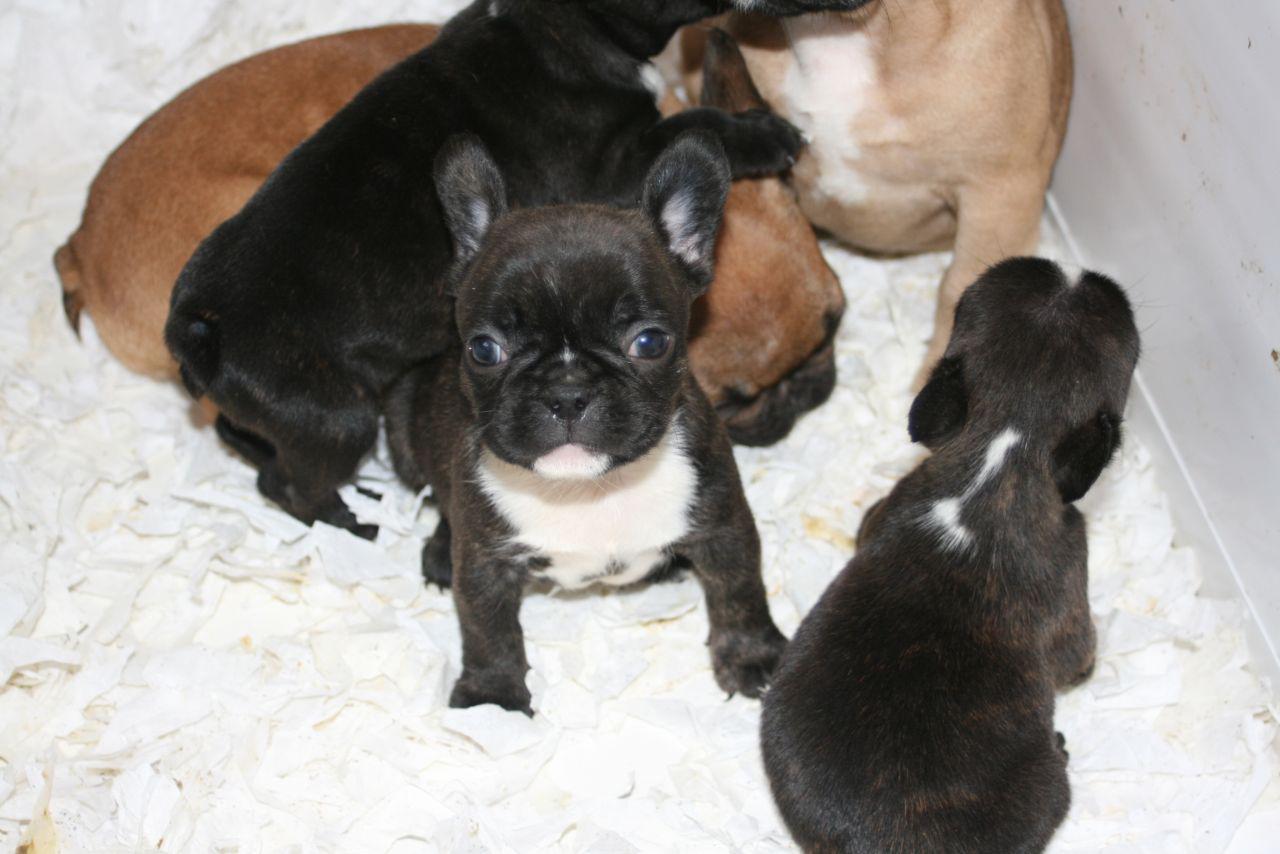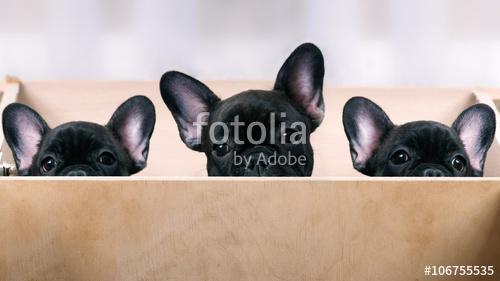The first image is the image on the left, the second image is the image on the right. Assess this claim about the two images: "The right image contains exactly three dogs.". Correct or not? Answer yes or no. Yes. The first image is the image on the left, the second image is the image on the right. Assess this claim about the two images: "There are no more than five puppies in the pair of images.". Correct or not? Answer yes or no. No. 